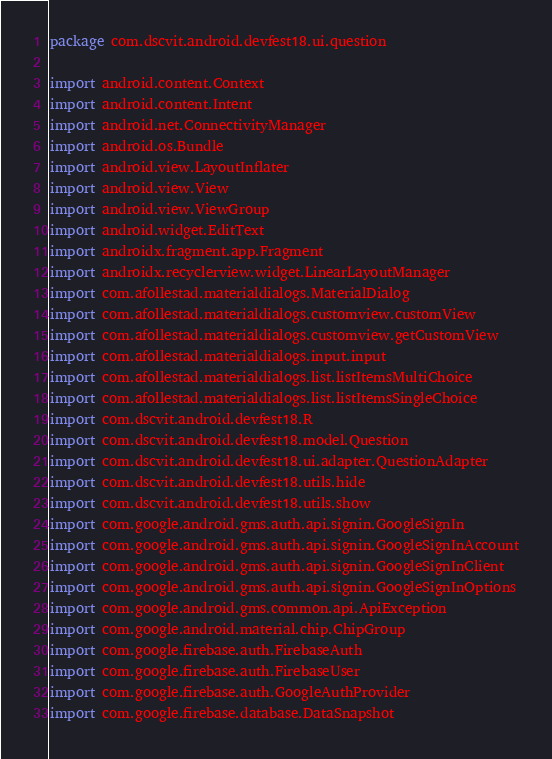Convert code to text. <code><loc_0><loc_0><loc_500><loc_500><_Kotlin_>package com.dscvit.android.devfest18.ui.question

import android.content.Context
import android.content.Intent
import android.net.ConnectivityManager
import android.os.Bundle
import android.view.LayoutInflater
import android.view.View
import android.view.ViewGroup
import android.widget.EditText
import androidx.fragment.app.Fragment
import androidx.recyclerview.widget.LinearLayoutManager
import com.afollestad.materialdialogs.MaterialDialog
import com.afollestad.materialdialogs.customview.customView
import com.afollestad.materialdialogs.customview.getCustomView
import com.afollestad.materialdialogs.input.input
import com.afollestad.materialdialogs.list.listItemsMultiChoice
import com.afollestad.materialdialogs.list.listItemsSingleChoice
import com.dscvit.android.devfest18.R
import com.dscvit.android.devfest18.model.Question
import com.dscvit.android.devfest18.ui.adapter.QuestionAdapter
import com.dscvit.android.devfest18.utils.hide
import com.dscvit.android.devfest18.utils.show
import com.google.android.gms.auth.api.signin.GoogleSignIn
import com.google.android.gms.auth.api.signin.GoogleSignInAccount
import com.google.android.gms.auth.api.signin.GoogleSignInClient
import com.google.android.gms.auth.api.signin.GoogleSignInOptions
import com.google.android.gms.common.api.ApiException
import com.google.android.material.chip.ChipGroup
import com.google.firebase.auth.FirebaseAuth
import com.google.firebase.auth.FirebaseUser
import com.google.firebase.auth.GoogleAuthProvider
import com.google.firebase.database.DataSnapshot</code> 